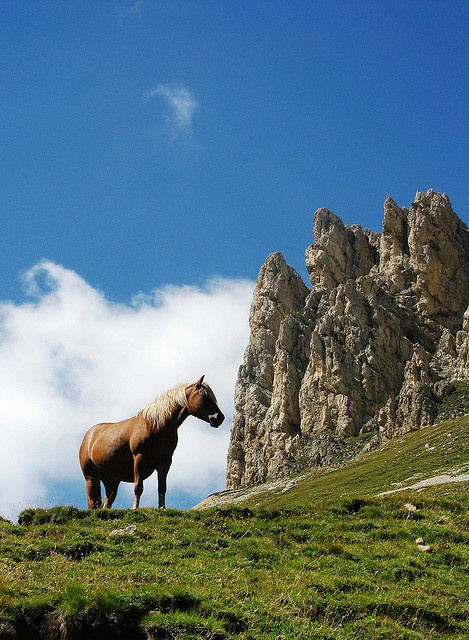Describe the objects in this image and their specific colors. I can see a horse in blue, black, lightgray, brown, and tan tones in this image. 